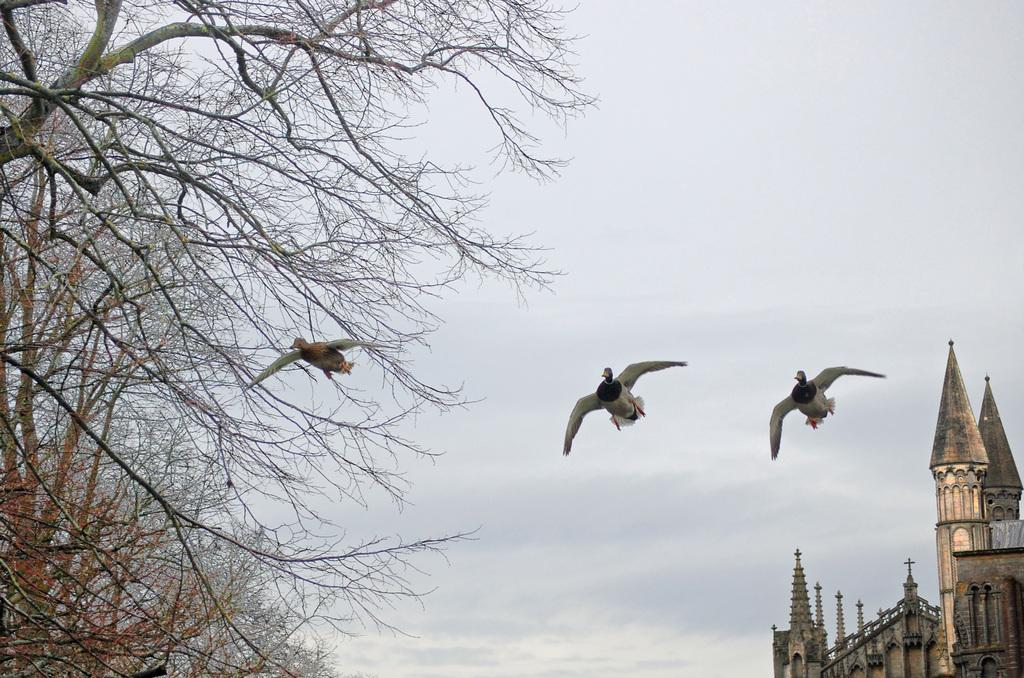What is happening in the sky in the image? There are birds flying in the air in the image. What can be seen on the left side of the image? There are trees on the left side of the image. What part of a building is visible in the image? The top part of a building is visible in the bottom right corner of the image. What is visible in the background of the image? The sky is visible in the background of the image. Where is the dock located in the image? There is no dock present in the image. What type of cherry is being taught in the image? There is no teaching or cherry present in the image. 